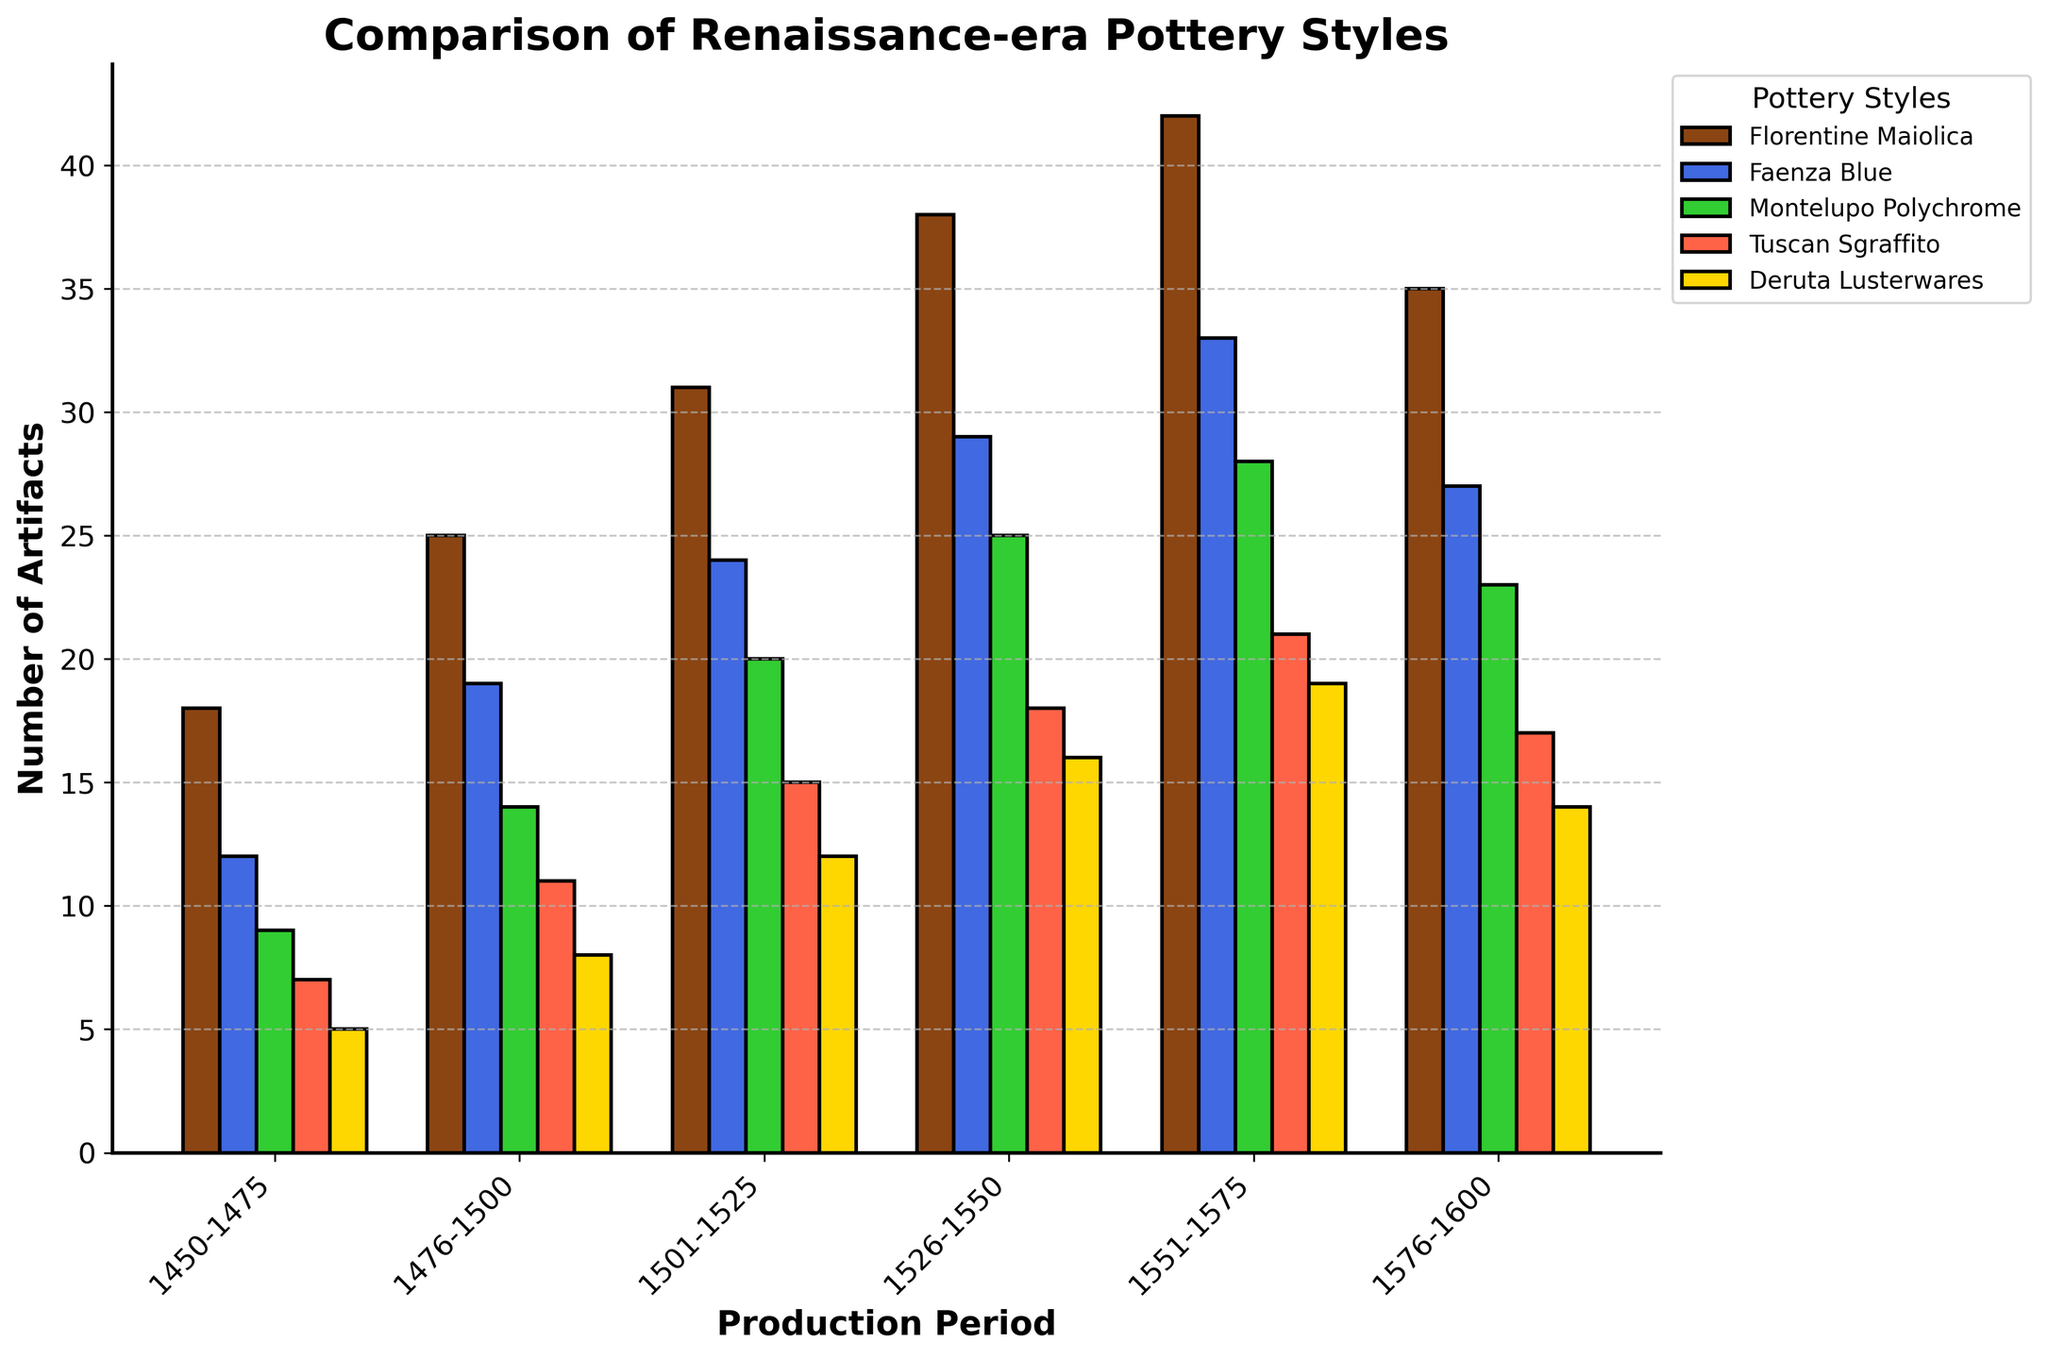Which pottery style had the highest number of artifacts in the period 1551-1575? Look at the bars for the period 1551-1575. The tallest bar represents Florentine Maiolica.
Answer: Florentine Maiolica Between which two consecutive periods did Faenza Blue show the highest increase in artifacts? Compare the heights of the bars for Faenza Blue across consecutive periods. The largest increase is from 1526-1550 to 1551-1575.
Answer: 1526-1550 to 1551-1575 How many total Montelupo Polychrome artifacts were found from 1501 to 1575? Sum the values of Montelupo Polychrome artifacts from 1501-1525, 1526-1550, and 1551-1575: 20 + 25 + 28.
Answer: 73 Which period saw a decline in the number of Deruta Lusterwares artifacts compared to its preceding period? Compare the heights of the Deruta Lusterwares bars for all periods. The decline occurs from 1551-1575 to 1576-1600.
Answer: 1576-1600 What is the average number of Tuscan Sgraffito artifacts from 1450 to 1600? Add the number of Tuscan Sgraffito artifacts for all periods and divide by the number of periods: (7 + 11 + 15 + 18 + 21 + 17) / 6.
Answer: 14.83 Which pottery style shows the least variation in the number of artifacts across all periods? Visually inspect the variations in bar heights for each pottery style. Montelupo Polychrome has the least variation.
Answer: Montelupo Polychrome In the period 1476-1500, which pottery style had almost twice the number of artifacts as Tuscan Sgraffito? Compare the number of Tuscan Sgraffito artifacts (11) and find the style close to twice that number (around 22). Faenza Blue with 19 artifacts is the closest.
Answer: Faenza Blue What is the difference in the number of Florentine Maiolica artifacts between the periods 1450-1475 and 1576-1600? Subtract the number of Florentine Maiolica artifacts in 1450-1475 (18) from those in 1576-1600 (35).
Answer: 17 For the period 1501-1525, arrange the pottery styles from the most artifacts to the least artifacts. Visually compare the heights of the bars for each pottery style in the period 1501-1525. The order is: Florentine Maiolica, Faenza Blue, Montelupo Polychrome, Tuscan Sgraffito, Deruta Lusterwares.
Answer: Florentine Maiolica, Faenza Blue, Montelupo Polychrome, Tuscan Sgraffito, Deruta Lusterwares What percentage of the total Florentine Maiolica artifacts observed from 1450-1600 were produced in the period 1551-1575? Sum all Florentine Maiolica artifacts from 1450-1600 (18 + 25 + 31 + 38 + 42 + 35 = 189); then calculate the percentage for the period 1551-1575 (42/189 * 100).
Answer: 22.22% 